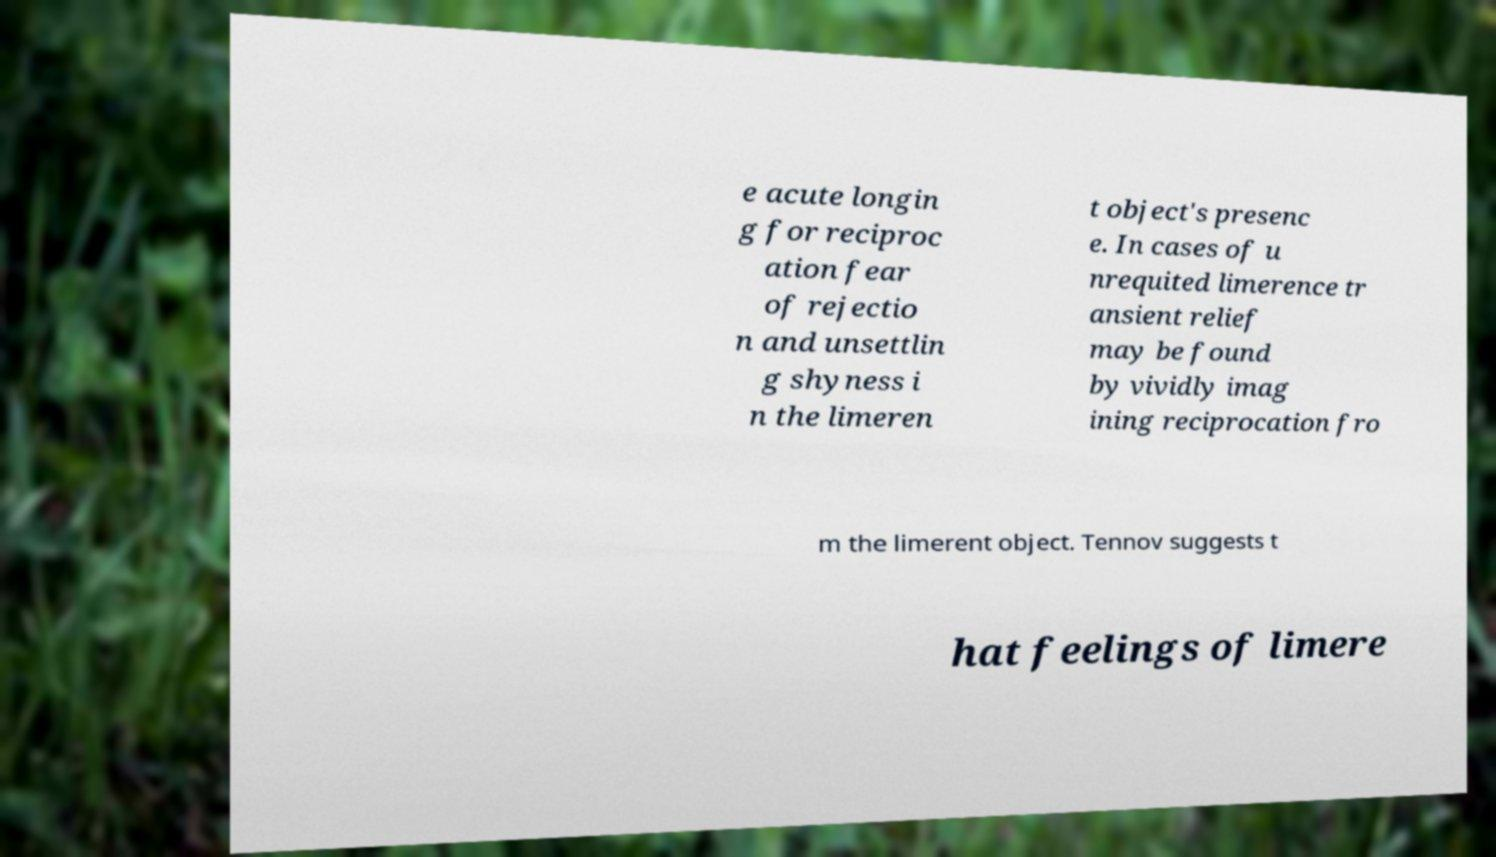Could you extract and type out the text from this image? e acute longin g for reciproc ation fear of rejectio n and unsettlin g shyness i n the limeren t object's presenc e. In cases of u nrequited limerence tr ansient relief may be found by vividly imag ining reciprocation fro m the limerent object. Tennov suggests t hat feelings of limere 